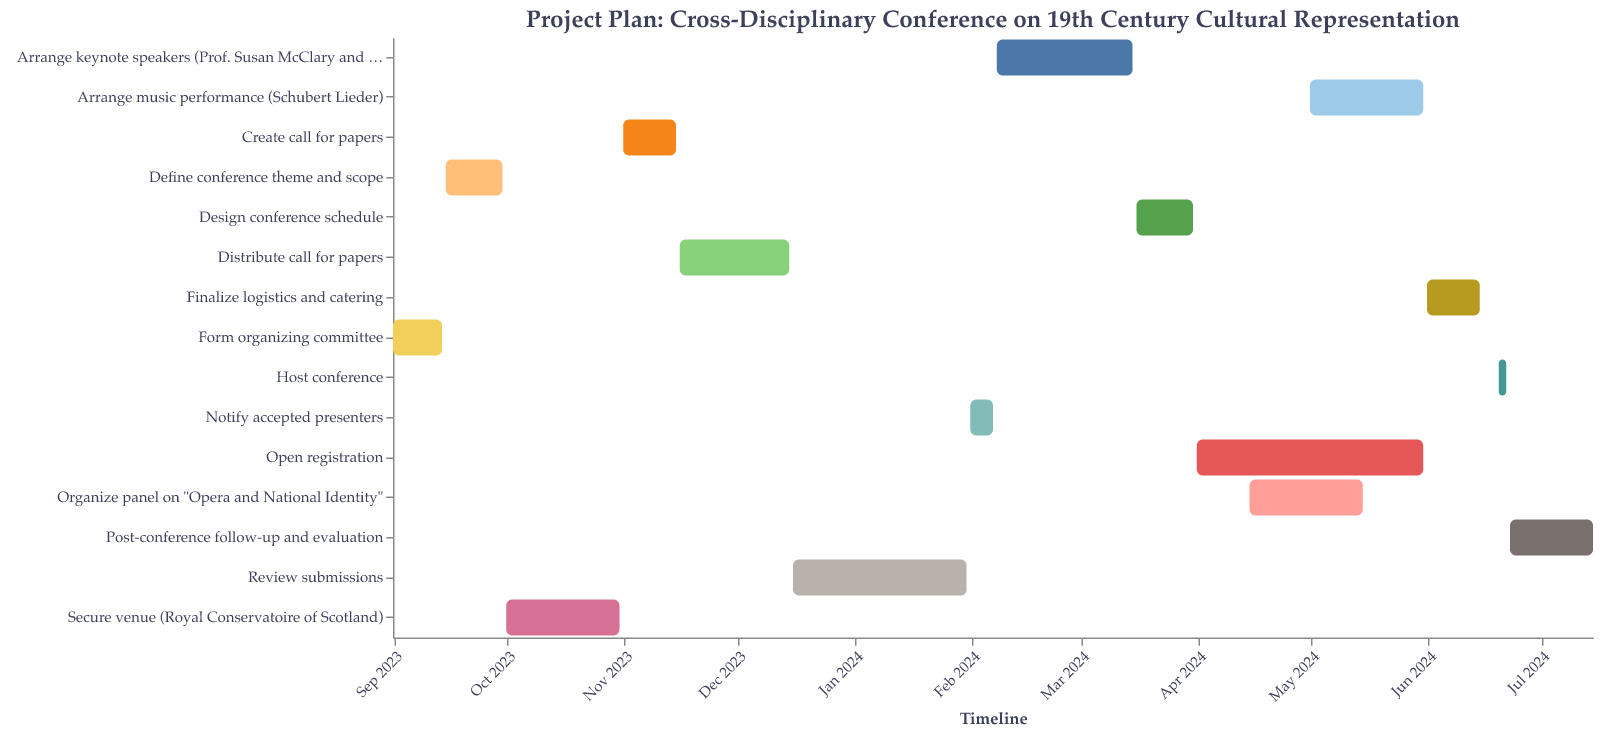What is the title of the project plan? The title is displayed at the top of the chart in a large font. It reads "Project Plan: Cross-Disciplinary Conference on 19th Century Cultural Representation".
Answer: Project Plan: Cross-Disciplinary Conference on 19th Century Cultural Representation When does the task "Secure venue" end? Look at the bar labeled "Secure venue (Royal Conservatoire of Scotland)" and check the corresponding end date at the right edge. It ends on October 31, 2023.
Answer: October 31, 2023 Which task lasts the longest? By looking at the duration of the bars and referring to their lengths, find the one with the maximum duration. "Open registration" has a duration of 61 days, which is the longest.
Answer: Open registration Which two tasks overlap in April 2024? Locate the tasks on the timeline for April 2024. Both "Open registration" and "Organize panel on 'Opera and National Identity'" overlap here.
Answer: Open registration and Organize panel on "Opera and National Identity" What is the duration of the task "Review submissions"? Refer to the bar labeled "Review submissions" and check the duration provided. The duration is 47 days.
Answer: 47 days How long after forming the organizing committee do we secure the venue? Check when the committee is formed (ends on September 14, 2023) and when securing the venue starts (October 1, 2023). Calculate the days between these dates. There are 17 days between September 14 and October 1.
Answer: 17 days What is the gap between the end of "Finalize logistics and catering" and the start of "Host conference"? Identify the end date of "Finalize logistics and catering" (June 15, 2024) and the start date of "Host conference" (June 20, 2024). The gap is 5 days.
Answer: 5 days Which task requires arranging two specific keynote speakers? Look for the task involving keynote speakers in the chart. The task "Arrange keynote speakers (Prof. Susan McClary and Dr. Lawrence Kramer)" requires arranging them.
Answer: Arrange keynote speakers What tasks are ongoing during November 2023? Identify all tasks whose bars overlap with November 2023 on the chart. "Create call for papers" and "Distribute call for papers" are ongoing during this period.
Answer: Create call for papers and Distribute call for papers When does the task "Host conference" take place? Locate the bar labeled "Host conference" and look at the start and end dates on the timeline. It takes place from June 20 to June 22, 2024.
Answer: June 20 to June 22, 2024 